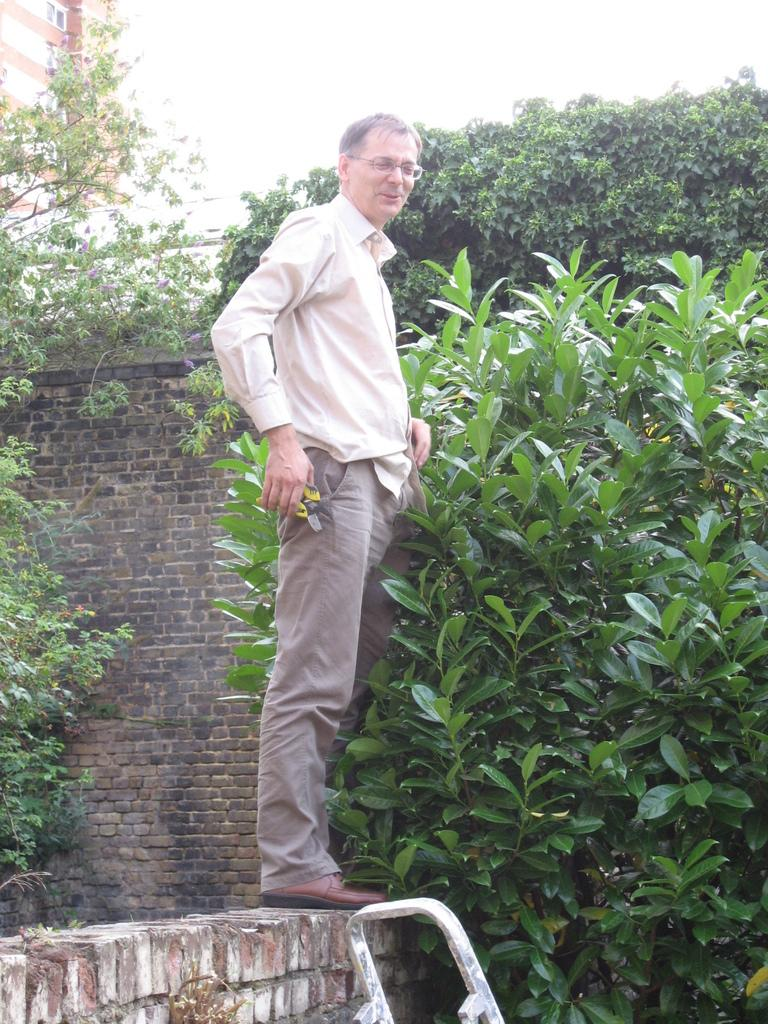What is the person in the image doing? The person is standing on a wall in the image. What can be seen in the background of the image? Trees and houses are visible in the image. What type of sugar is being used by the fireman in the image? There is no fireman or sugar present in the image. 